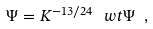<formula> <loc_0><loc_0><loc_500><loc_500>\Psi = K ^ { - 1 3 / 2 4 } \, \ w t \Psi \ ,</formula> 